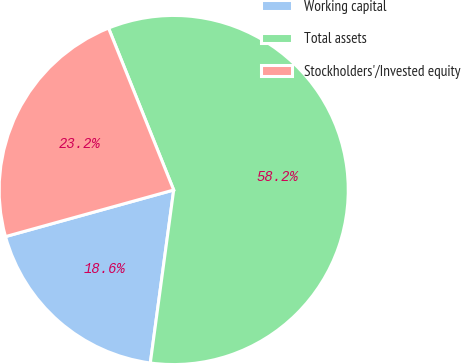<chart> <loc_0><loc_0><loc_500><loc_500><pie_chart><fcel>Working capital<fcel>Total assets<fcel>Stockholders'/Invested equity<nl><fcel>18.56%<fcel>58.23%<fcel>23.21%<nl></chart> 